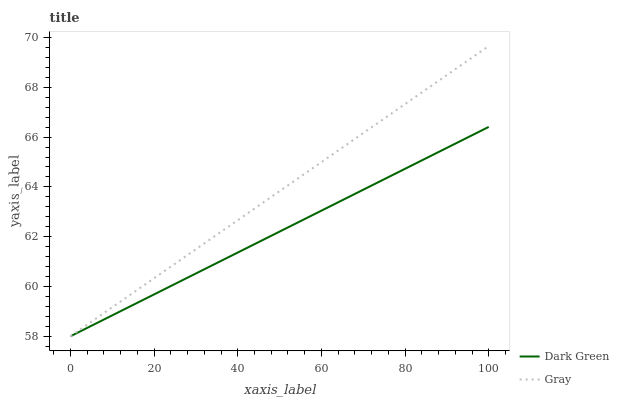Does Dark Green have the maximum area under the curve?
Answer yes or no. No. Is Dark Green the smoothest?
Answer yes or no. No. Does Dark Green have the highest value?
Answer yes or no. No. 